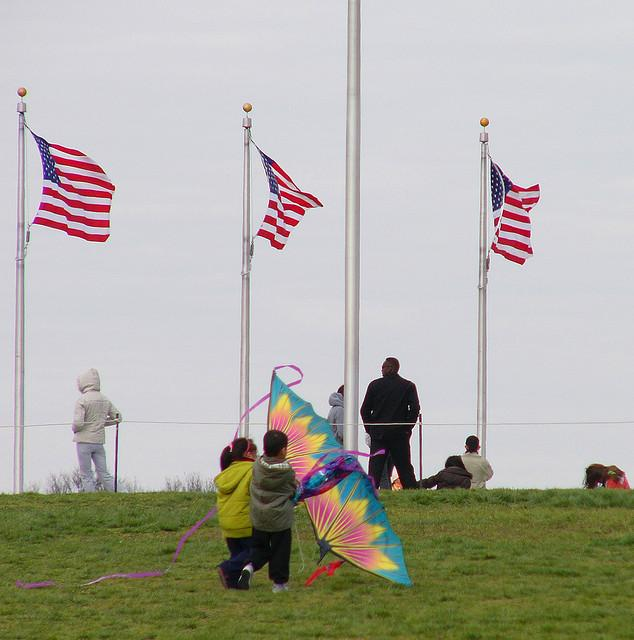What are the silver poles being used for? flags 